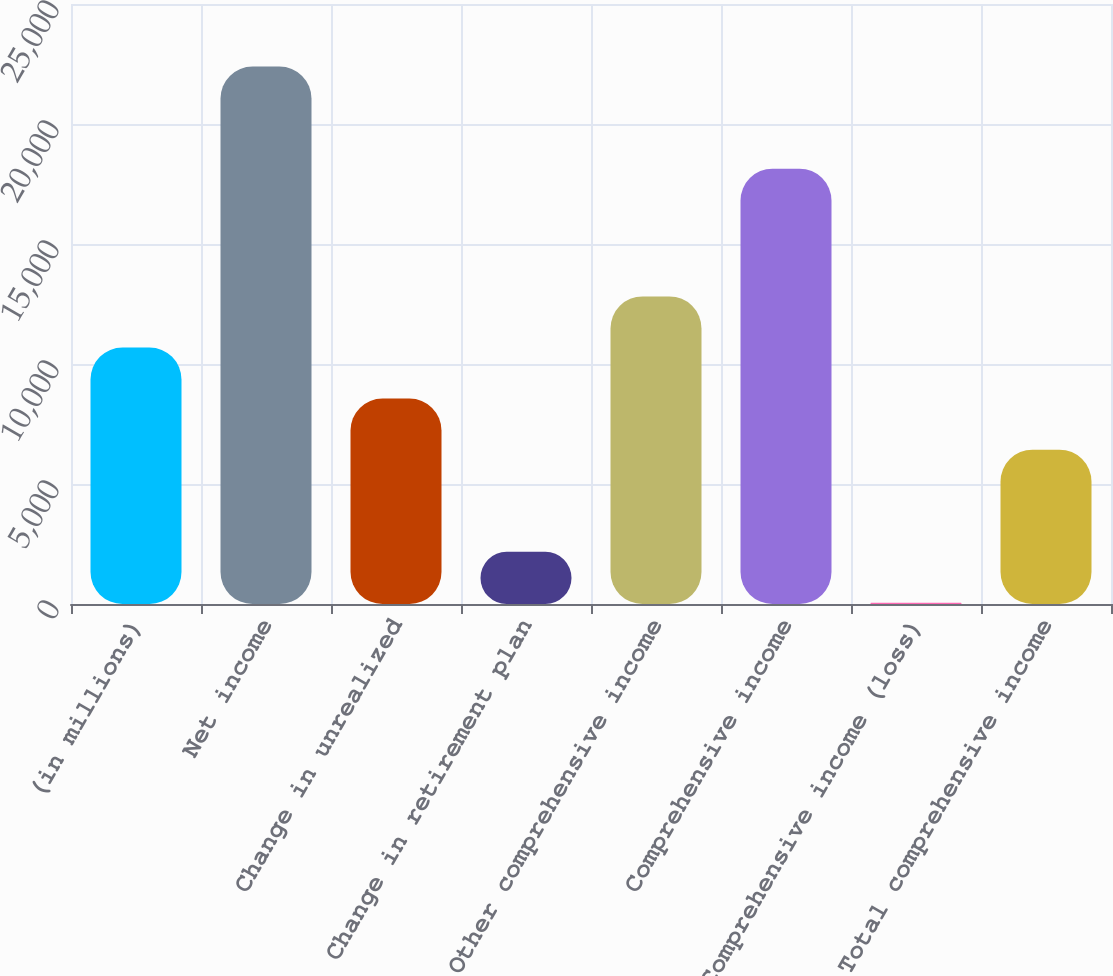<chart> <loc_0><loc_0><loc_500><loc_500><bar_chart><fcel>(in millions)<fcel>Net income<fcel>Change in unrealized<fcel>Change in retirement plan<fcel>Other comprehensive income<fcel>Comprehensive income<fcel>Comprehensive income (loss)<fcel>Total comprehensive income<nl><fcel>10688.5<fcel>22395.6<fcel>8560.2<fcel>2175.3<fcel>12816.8<fcel>18139<fcel>47<fcel>6431.9<nl></chart> 